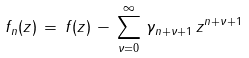Convert formula to latex. <formula><loc_0><loc_0><loc_500><loc_500>f _ { n } ( z ) \, = \, f ( z ) \, - \, \sum _ { \nu = 0 } ^ { \infty } \, \gamma _ { n + \nu + 1 } \, z ^ { n + \nu + 1 }</formula> 